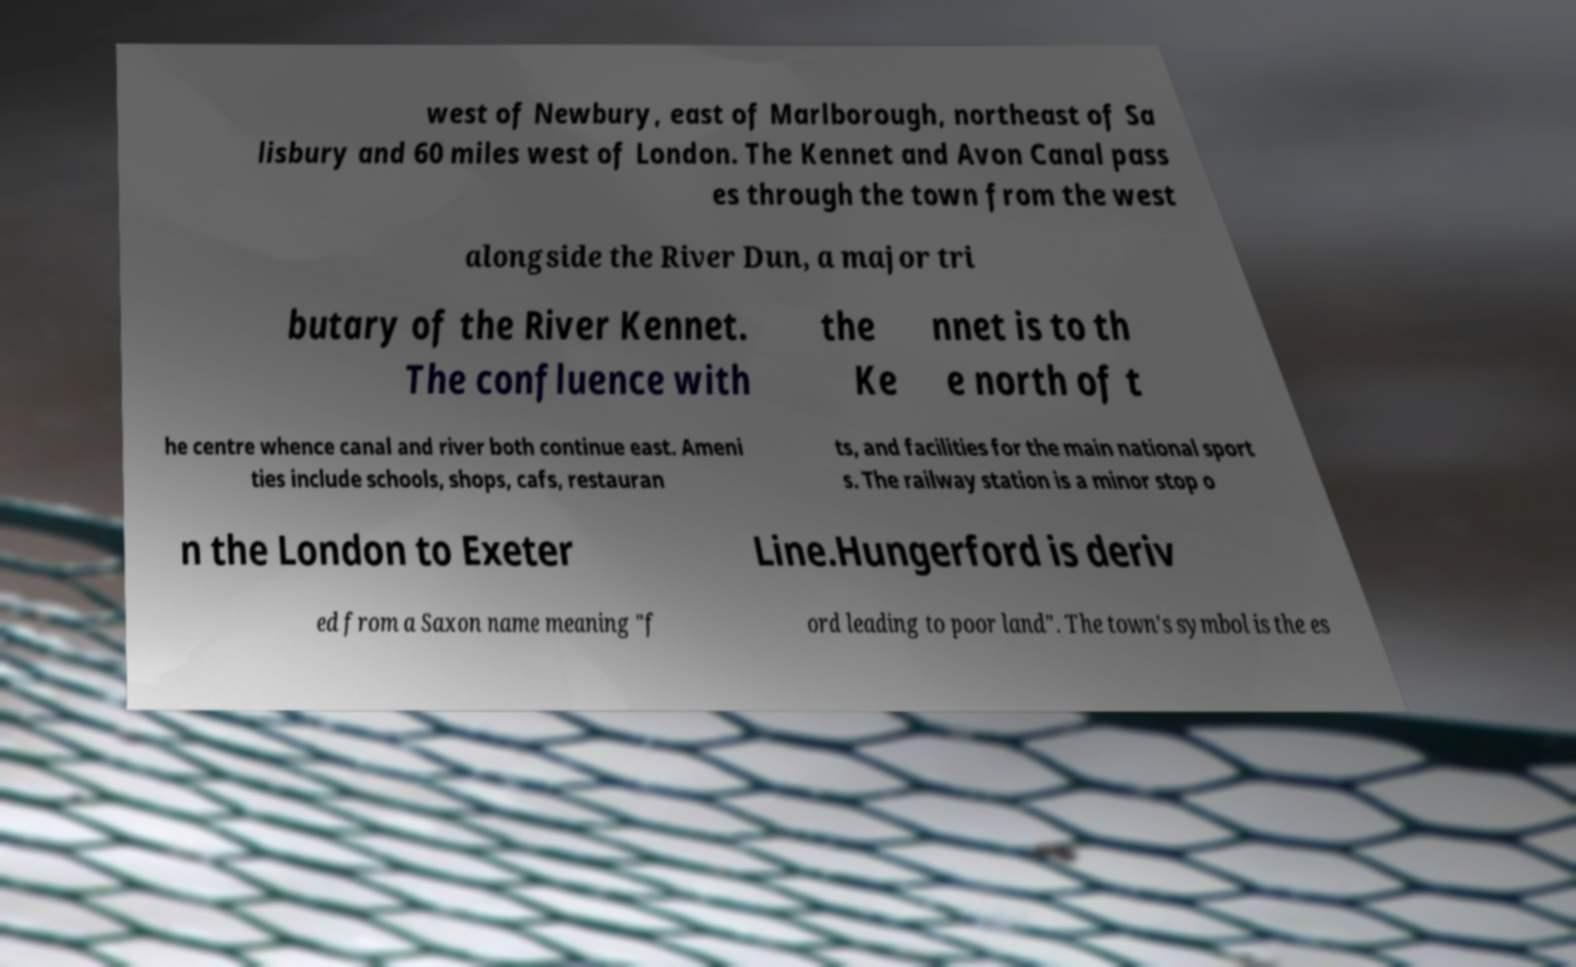Please identify and transcribe the text found in this image. west of Newbury, east of Marlborough, northeast of Sa lisbury and 60 miles west of London. The Kennet and Avon Canal pass es through the town from the west alongside the River Dun, a major tri butary of the River Kennet. The confluence with the Ke nnet is to th e north of t he centre whence canal and river both continue east. Ameni ties include schools, shops, cafs, restauran ts, and facilities for the main national sport s. The railway station is a minor stop o n the London to Exeter Line.Hungerford is deriv ed from a Saxon name meaning "f ord leading to poor land". The town's symbol is the es 